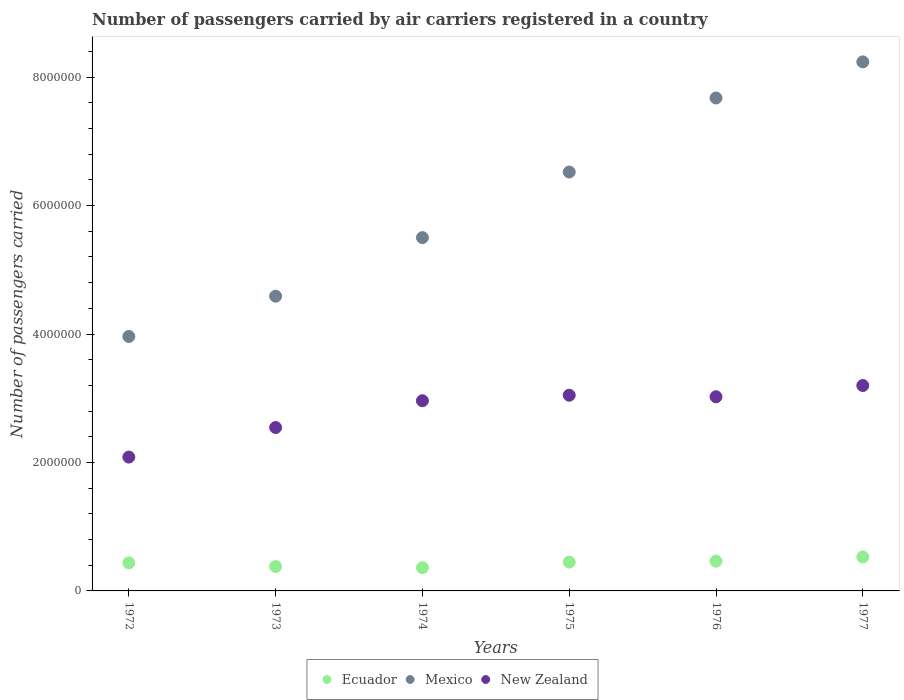How many different coloured dotlines are there?
Your response must be concise. 3. What is the number of passengers carried by air carriers in Ecuador in 1972?
Provide a short and direct response. 4.38e+05. Across all years, what is the maximum number of passengers carried by air carriers in Mexico?
Keep it short and to the point. 8.24e+06. Across all years, what is the minimum number of passengers carried by air carriers in Mexico?
Give a very brief answer. 3.96e+06. In which year was the number of passengers carried by air carriers in New Zealand maximum?
Offer a terse response. 1977. In which year was the number of passengers carried by air carriers in Ecuador minimum?
Offer a terse response. 1974. What is the total number of passengers carried by air carriers in Ecuador in the graph?
Your answer should be very brief. 2.62e+06. What is the difference between the number of passengers carried by air carriers in Ecuador in 1974 and that in 1975?
Provide a succinct answer. -8.59e+04. What is the difference between the number of passengers carried by air carriers in New Zealand in 1973 and the number of passengers carried by air carriers in Mexico in 1974?
Provide a short and direct response. -2.96e+06. What is the average number of passengers carried by air carriers in Ecuador per year?
Give a very brief answer. 4.37e+05. In the year 1974, what is the difference between the number of passengers carried by air carriers in Mexico and number of passengers carried by air carriers in Ecuador?
Ensure brevity in your answer.  5.14e+06. In how many years, is the number of passengers carried by air carriers in New Zealand greater than 6800000?
Your answer should be compact. 0. What is the ratio of the number of passengers carried by air carriers in Mexico in 1972 to that in 1973?
Give a very brief answer. 0.86. Is the difference between the number of passengers carried by air carriers in Mexico in 1972 and 1977 greater than the difference between the number of passengers carried by air carriers in Ecuador in 1972 and 1977?
Your answer should be very brief. No. What is the difference between the highest and the second highest number of passengers carried by air carriers in Mexico?
Your answer should be compact. 5.62e+05. What is the difference between the highest and the lowest number of passengers carried by air carriers in Ecuador?
Make the answer very short. 1.66e+05. In how many years, is the number of passengers carried by air carriers in New Zealand greater than the average number of passengers carried by air carriers in New Zealand taken over all years?
Offer a very short reply. 4. How many years are there in the graph?
Provide a short and direct response. 6. Does the graph contain any zero values?
Provide a succinct answer. No. Does the graph contain grids?
Your answer should be compact. No. Where does the legend appear in the graph?
Make the answer very short. Bottom center. What is the title of the graph?
Provide a short and direct response. Number of passengers carried by air carriers registered in a country. Does "Mauritius" appear as one of the legend labels in the graph?
Provide a short and direct response. No. What is the label or title of the X-axis?
Make the answer very short. Years. What is the label or title of the Y-axis?
Keep it short and to the point. Number of passengers carried. What is the Number of passengers carried in Ecuador in 1972?
Offer a terse response. 4.38e+05. What is the Number of passengers carried of Mexico in 1972?
Provide a short and direct response. 3.96e+06. What is the Number of passengers carried of New Zealand in 1972?
Offer a very short reply. 2.08e+06. What is the Number of passengers carried in Ecuador in 1973?
Provide a succinct answer. 3.80e+05. What is the Number of passengers carried in Mexico in 1973?
Your answer should be very brief. 4.59e+06. What is the Number of passengers carried in New Zealand in 1973?
Make the answer very short. 2.54e+06. What is the Number of passengers carried of Ecuador in 1974?
Offer a very short reply. 3.62e+05. What is the Number of passengers carried in Mexico in 1974?
Offer a very short reply. 5.50e+06. What is the Number of passengers carried in New Zealand in 1974?
Offer a terse response. 2.96e+06. What is the Number of passengers carried in Ecuador in 1975?
Give a very brief answer. 4.48e+05. What is the Number of passengers carried of Mexico in 1975?
Offer a very short reply. 6.52e+06. What is the Number of passengers carried of New Zealand in 1975?
Your answer should be very brief. 3.05e+06. What is the Number of passengers carried of Ecuador in 1976?
Ensure brevity in your answer.  4.63e+05. What is the Number of passengers carried of Mexico in 1976?
Your answer should be compact. 7.68e+06. What is the Number of passengers carried of New Zealand in 1976?
Offer a very short reply. 3.02e+06. What is the Number of passengers carried of Ecuador in 1977?
Your answer should be very brief. 5.29e+05. What is the Number of passengers carried of Mexico in 1977?
Ensure brevity in your answer.  8.24e+06. What is the Number of passengers carried of New Zealand in 1977?
Your response must be concise. 3.20e+06. Across all years, what is the maximum Number of passengers carried in Ecuador?
Your response must be concise. 5.29e+05. Across all years, what is the maximum Number of passengers carried in Mexico?
Your response must be concise. 8.24e+06. Across all years, what is the maximum Number of passengers carried in New Zealand?
Keep it short and to the point. 3.20e+06. Across all years, what is the minimum Number of passengers carried of Ecuador?
Your response must be concise. 3.62e+05. Across all years, what is the minimum Number of passengers carried of Mexico?
Your response must be concise. 3.96e+06. Across all years, what is the minimum Number of passengers carried in New Zealand?
Offer a very short reply. 2.08e+06. What is the total Number of passengers carried in Ecuador in the graph?
Offer a very short reply. 2.62e+06. What is the total Number of passengers carried in Mexico in the graph?
Keep it short and to the point. 3.65e+07. What is the total Number of passengers carried of New Zealand in the graph?
Make the answer very short. 1.69e+07. What is the difference between the Number of passengers carried of Ecuador in 1972 and that in 1973?
Your response must be concise. 5.76e+04. What is the difference between the Number of passengers carried in Mexico in 1972 and that in 1973?
Your response must be concise. -6.28e+05. What is the difference between the Number of passengers carried of New Zealand in 1972 and that in 1973?
Give a very brief answer. -4.60e+05. What is the difference between the Number of passengers carried in Ecuador in 1972 and that in 1974?
Provide a short and direct response. 7.56e+04. What is the difference between the Number of passengers carried of Mexico in 1972 and that in 1974?
Your answer should be very brief. -1.54e+06. What is the difference between the Number of passengers carried in New Zealand in 1972 and that in 1974?
Offer a very short reply. -8.77e+05. What is the difference between the Number of passengers carried in Ecuador in 1972 and that in 1975?
Provide a short and direct response. -1.03e+04. What is the difference between the Number of passengers carried in Mexico in 1972 and that in 1975?
Give a very brief answer. -2.56e+06. What is the difference between the Number of passengers carried of New Zealand in 1972 and that in 1975?
Keep it short and to the point. -9.63e+05. What is the difference between the Number of passengers carried of Ecuador in 1972 and that in 1976?
Provide a succinct answer. -2.55e+04. What is the difference between the Number of passengers carried in Mexico in 1972 and that in 1976?
Provide a short and direct response. -3.71e+06. What is the difference between the Number of passengers carried in New Zealand in 1972 and that in 1976?
Make the answer very short. -9.39e+05. What is the difference between the Number of passengers carried in Ecuador in 1972 and that in 1977?
Your answer should be very brief. -9.08e+04. What is the difference between the Number of passengers carried in Mexico in 1972 and that in 1977?
Keep it short and to the point. -4.28e+06. What is the difference between the Number of passengers carried of New Zealand in 1972 and that in 1977?
Provide a short and direct response. -1.11e+06. What is the difference between the Number of passengers carried of Ecuador in 1973 and that in 1974?
Offer a terse response. 1.80e+04. What is the difference between the Number of passengers carried in Mexico in 1973 and that in 1974?
Keep it short and to the point. -9.12e+05. What is the difference between the Number of passengers carried of New Zealand in 1973 and that in 1974?
Provide a short and direct response. -4.17e+05. What is the difference between the Number of passengers carried of Ecuador in 1973 and that in 1975?
Offer a terse response. -6.79e+04. What is the difference between the Number of passengers carried of Mexico in 1973 and that in 1975?
Your response must be concise. -1.93e+06. What is the difference between the Number of passengers carried in New Zealand in 1973 and that in 1975?
Ensure brevity in your answer.  -5.03e+05. What is the difference between the Number of passengers carried of Ecuador in 1973 and that in 1976?
Keep it short and to the point. -8.31e+04. What is the difference between the Number of passengers carried of Mexico in 1973 and that in 1976?
Your answer should be very brief. -3.09e+06. What is the difference between the Number of passengers carried of New Zealand in 1973 and that in 1976?
Give a very brief answer. -4.79e+05. What is the difference between the Number of passengers carried of Ecuador in 1973 and that in 1977?
Make the answer very short. -1.48e+05. What is the difference between the Number of passengers carried in Mexico in 1973 and that in 1977?
Offer a terse response. -3.65e+06. What is the difference between the Number of passengers carried in New Zealand in 1973 and that in 1977?
Your response must be concise. -6.54e+05. What is the difference between the Number of passengers carried of Ecuador in 1974 and that in 1975?
Make the answer very short. -8.59e+04. What is the difference between the Number of passengers carried in Mexico in 1974 and that in 1975?
Offer a very short reply. -1.02e+06. What is the difference between the Number of passengers carried of New Zealand in 1974 and that in 1975?
Ensure brevity in your answer.  -8.61e+04. What is the difference between the Number of passengers carried of Ecuador in 1974 and that in 1976?
Keep it short and to the point. -1.01e+05. What is the difference between the Number of passengers carried in Mexico in 1974 and that in 1976?
Give a very brief answer. -2.17e+06. What is the difference between the Number of passengers carried of New Zealand in 1974 and that in 1976?
Make the answer very short. -6.19e+04. What is the difference between the Number of passengers carried in Ecuador in 1974 and that in 1977?
Ensure brevity in your answer.  -1.66e+05. What is the difference between the Number of passengers carried of Mexico in 1974 and that in 1977?
Ensure brevity in your answer.  -2.74e+06. What is the difference between the Number of passengers carried in New Zealand in 1974 and that in 1977?
Provide a short and direct response. -2.37e+05. What is the difference between the Number of passengers carried of Ecuador in 1975 and that in 1976?
Offer a very short reply. -1.52e+04. What is the difference between the Number of passengers carried of Mexico in 1975 and that in 1976?
Offer a terse response. -1.15e+06. What is the difference between the Number of passengers carried of New Zealand in 1975 and that in 1976?
Your answer should be very brief. 2.42e+04. What is the difference between the Number of passengers carried of Ecuador in 1975 and that in 1977?
Keep it short and to the point. -8.05e+04. What is the difference between the Number of passengers carried in Mexico in 1975 and that in 1977?
Make the answer very short. -1.72e+06. What is the difference between the Number of passengers carried of New Zealand in 1975 and that in 1977?
Your answer should be very brief. -1.51e+05. What is the difference between the Number of passengers carried of Ecuador in 1976 and that in 1977?
Provide a succinct answer. -6.53e+04. What is the difference between the Number of passengers carried of Mexico in 1976 and that in 1977?
Keep it short and to the point. -5.62e+05. What is the difference between the Number of passengers carried in New Zealand in 1976 and that in 1977?
Give a very brief answer. -1.75e+05. What is the difference between the Number of passengers carried of Ecuador in 1972 and the Number of passengers carried of Mexico in 1973?
Make the answer very short. -4.15e+06. What is the difference between the Number of passengers carried of Ecuador in 1972 and the Number of passengers carried of New Zealand in 1973?
Your answer should be compact. -2.11e+06. What is the difference between the Number of passengers carried in Mexico in 1972 and the Number of passengers carried in New Zealand in 1973?
Ensure brevity in your answer.  1.42e+06. What is the difference between the Number of passengers carried in Ecuador in 1972 and the Number of passengers carried in Mexico in 1974?
Provide a short and direct response. -5.06e+06. What is the difference between the Number of passengers carried of Ecuador in 1972 and the Number of passengers carried of New Zealand in 1974?
Make the answer very short. -2.52e+06. What is the difference between the Number of passengers carried of Mexico in 1972 and the Number of passengers carried of New Zealand in 1974?
Offer a very short reply. 1.00e+06. What is the difference between the Number of passengers carried of Ecuador in 1972 and the Number of passengers carried of Mexico in 1975?
Your response must be concise. -6.09e+06. What is the difference between the Number of passengers carried of Ecuador in 1972 and the Number of passengers carried of New Zealand in 1975?
Your answer should be very brief. -2.61e+06. What is the difference between the Number of passengers carried in Mexico in 1972 and the Number of passengers carried in New Zealand in 1975?
Ensure brevity in your answer.  9.15e+05. What is the difference between the Number of passengers carried in Ecuador in 1972 and the Number of passengers carried in Mexico in 1976?
Keep it short and to the point. -7.24e+06. What is the difference between the Number of passengers carried of Ecuador in 1972 and the Number of passengers carried of New Zealand in 1976?
Provide a succinct answer. -2.59e+06. What is the difference between the Number of passengers carried in Mexico in 1972 and the Number of passengers carried in New Zealand in 1976?
Offer a very short reply. 9.39e+05. What is the difference between the Number of passengers carried of Ecuador in 1972 and the Number of passengers carried of Mexico in 1977?
Ensure brevity in your answer.  -7.80e+06. What is the difference between the Number of passengers carried in Ecuador in 1972 and the Number of passengers carried in New Zealand in 1977?
Ensure brevity in your answer.  -2.76e+06. What is the difference between the Number of passengers carried of Mexico in 1972 and the Number of passengers carried of New Zealand in 1977?
Ensure brevity in your answer.  7.64e+05. What is the difference between the Number of passengers carried of Ecuador in 1973 and the Number of passengers carried of Mexico in 1974?
Your answer should be compact. -5.12e+06. What is the difference between the Number of passengers carried of Ecuador in 1973 and the Number of passengers carried of New Zealand in 1974?
Ensure brevity in your answer.  -2.58e+06. What is the difference between the Number of passengers carried in Mexico in 1973 and the Number of passengers carried in New Zealand in 1974?
Your answer should be very brief. 1.63e+06. What is the difference between the Number of passengers carried in Ecuador in 1973 and the Number of passengers carried in Mexico in 1975?
Offer a very short reply. -6.14e+06. What is the difference between the Number of passengers carried in Ecuador in 1973 and the Number of passengers carried in New Zealand in 1975?
Ensure brevity in your answer.  -2.67e+06. What is the difference between the Number of passengers carried in Mexico in 1973 and the Number of passengers carried in New Zealand in 1975?
Your answer should be very brief. 1.54e+06. What is the difference between the Number of passengers carried of Ecuador in 1973 and the Number of passengers carried of Mexico in 1976?
Offer a very short reply. -7.30e+06. What is the difference between the Number of passengers carried in Ecuador in 1973 and the Number of passengers carried in New Zealand in 1976?
Offer a terse response. -2.64e+06. What is the difference between the Number of passengers carried of Mexico in 1973 and the Number of passengers carried of New Zealand in 1976?
Ensure brevity in your answer.  1.57e+06. What is the difference between the Number of passengers carried of Ecuador in 1973 and the Number of passengers carried of Mexico in 1977?
Offer a very short reply. -7.86e+06. What is the difference between the Number of passengers carried in Ecuador in 1973 and the Number of passengers carried in New Zealand in 1977?
Offer a terse response. -2.82e+06. What is the difference between the Number of passengers carried in Mexico in 1973 and the Number of passengers carried in New Zealand in 1977?
Your answer should be compact. 1.39e+06. What is the difference between the Number of passengers carried of Ecuador in 1974 and the Number of passengers carried of Mexico in 1975?
Make the answer very short. -6.16e+06. What is the difference between the Number of passengers carried of Ecuador in 1974 and the Number of passengers carried of New Zealand in 1975?
Give a very brief answer. -2.69e+06. What is the difference between the Number of passengers carried of Mexico in 1974 and the Number of passengers carried of New Zealand in 1975?
Provide a short and direct response. 2.45e+06. What is the difference between the Number of passengers carried in Ecuador in 1974 and the Number of passengers carried in Mexico in 1976?
Offer a very short reply. -7.31e+06. What is the difference between the Number of passengers carried in Ecuador in 1974 and the Number of passengers carried in New Zealand in 1976?
Offer a very short reply. -2.66e+06. What is the difference between the Number of passengers carried in Mexico in 1974 and the Number of passengers carried in New Zealand in 1976?
Keep it short and to the point. 2.48e+06. What is the difference between the Number of passengers carried of Ecuador in 1974 and the Number of passengers carried of Mexico in 1977?
Keep it short and to the point. -7.88e+06. What is the difference between the Number of passengers carried in Ecuador in 1974 and the Number of passengers carried in New Zealand in 1977?
Offer a very short reply. -2.84e+06. What is the difference between the Number of passengers carried in Mexico in 1974 and the Number of passengers carried in New Zealand in 1977?
Keep it short and to the point. 2.30e+06. What is the difference between the Number of passengers carried in Ecuador in 1975 and the Number of passengers carried in Mexico in 1976?
Offer a terse response. -7.23e+06. What is the difference between the Number of passengers carried in Ecuador in 1975 and the Number of passengers carried in New Zealand in 1976?
Provide a succinct answer. -2.58e+06. What is the difference between the Number of passengers carried in Mexico in 1975 and the Number of passengers carried in New Zealand in 1976?
Your answer should be compact. 3.50e+06. What is the difference between the Number of passengers carried of Ecuador in 1975 and the Number of passengers carried of Mexico in 1977?
Give a very brief answer. -7.79e+06. What is the difference between the Number of passengers carried of Ecuador in 1975 and the Number of passengers carried of New Zealand in 1977?
Your answer should be compact. -2.75e+06. What is the difference between the Number of passengers carried in Mexico in 1975 and the Number of passengers carried in New Zealand in 1977?
Your response must be concise. 3.32e+06. What is the difference between the Number of passengers carried of Ecuador in 1976 and the Number of passengers carried of Mexico in 1977?
Provide a succinct answer. -7.77e+06. What is the difference between the Number of passengers carried in Ecuador in 1976 and the Number of passengers carried in New Zealand in 1977?
Your answer should be compact. -2.74e+06. What is the difference between the Number of passengers carried in Mexico in 1976 and the Number of passengers carried in New Zealand in 1977?
Ensure brevity in your answer.  4.48e+06. What is the average Number of passengers carried of Ecuador per year?
Ensure brevity in your answer.  4.37e+05. What is the average Number of passengers carried of Mexico per year?
Offer a very short reply. 6.08e+06. What is the average Number of passengers carried of New Zealand per year?
Your response must be concise. 2.81e+06. In the year 1972, what is the difference between the Number of passengers carried of Ecuador and Number of passengers carried of Mexico?
Make the answer very short. -3.52e+06. In the year 1972, what is the difference between the Number of passengers carried of Ecuador and Number of passengers carried of New Zealand?
Your response must be concise. -1.65e+06. In the year 1972, what is the difference between the Number of passengers carried in Mexico and Number of passengers carried in New Zealand?
Offer a terse response. 1.88e+06. In the year 1973, what is the difference between the Number of passengers carried in Ecuador and Number of passengers carried in Mexico?
Offer a terse response. -4.21e+06. In the year 1973, what is the difference between the Number of passengers carried in Ecuador and Number of passengers carried in New Zealand?
Provide a succinct answer. -2.16e+06. In the year 1973, what is the difference between the Number of passengers carried of Mexico and Number of passengers carried of New Zealand?
Make the answer very short. 2.05e+06. In the year 1974, what is the difference between the Number of passengers carried in Ecuador and Number of passengers carried in Mexico?
Keep it short and to the point. -5.14e+06. In the year 1974, what is the difference between the Number of passengers carried of Ecuador and Number of passengers carried of New Zealand?
Give a very brief answer. -2.60e+06. In the year 1974, what is the difference between the Number of passengers carried of Mexico and Number of passengers carried of New Zealand?
Your answer should be very brief. 2.54e+06. In the year 1975, what is the difference between the Number of passengers carried of Ecuador and Number of passengers carried of Mexico?
Make the answer very short. -6.07e+06. In the year 1975, what is the difference between the Number of passengers carried of Ecuador and Number of passengers carried of New Zealand?
Your answer should be very brief. -2.60e+06. In the year 1975, what is the difference between the Number of passengers carried of Mexico and Number of passengers carried of New Zealand?
Provide a succinct answer. 3.48e+06. In the year 1976, what is the difference between the Number of passengers carried in Ecuador and Number of passengers carried in Mexico?
Keep it short and to the point. -7.21e+06. In the year 1976, what is the difference between the Number of passengers carried of Ecuador and Number of passengers carried of New Zealand?
Offer a very short reply. -2.56e+06. In the year 1976, what is the difference between the Number of passengers carried of Mexico and Number of passengers carried of New Zealand?
Provide a succinct answer. 4.65e+06. In the year 1977, what is the difference between the Number of passengers carried of Ecuador and Number of passengers carried of Mexico?
Your answer should be very brief. -7.71e+06. In the year 1977, what is the difference between the Number of passengers carried in Ecuador and Number of passengers carried in New Zealand?
Your response must be concise. -2.67e+06. In the year 1977, what is the difference between the Number of passengers carried of Mexico and Number of passengers carried of New Zealand?
Provide a succinct answer. 5.04e+06. What is the ratio of the Number of passengers carried in Ecuador in 1972 to that in 1973?
Provide a succinct answer. 1.15. What is the ratio of the Number of passengers carried of Mexico in 1972 to that in 1973?
Offer a terse response. 0.86. What is the ratio of the Number of passengers carried of New Zealand in 1972 to that in 1973?
Your response must be concise. 0.82. What is the ratio of the Number of passengers carried in Ecuador in 1972 to that in 1974?
Keep it short and to the point. 1.21. What is the ratio of the Number of passengers carried of Mexico in 1972 to that in 1974?
Ensure brevity in your answer.  0.72. What is the ratio of the Number of passengers carried of New Zealand in 1972 to that in 1974?
Provide a succinct answer. 0.7. What is the ratio of the Number of passengers carried in Mexico in 1972 to that in 1975?
Keep it short and to the point. 0.61. What is the ratio of the Number of passengers carried in New Zealand in 1972 to that in 1975?
Ensure brevity in your answer.  0.68. What is the ratio of the Number of passengers carried in Ecuador in 1972 to that in 1976?
Give a very brief answer. 0.94. What is the ratio of the Number of passengers carried of Mexico in 1972 to that in 1976?
Ensure brevity in your answer.  0.52. What is the ratio of the Number of passengers carried of New Zealand in 1972 to that in 1976?
Your answer should be compact. 0.69. What is the ratio of the Number of passengers carried in Ecuador in 1972 to that in 1977?
Provide a short and direct response. 0.83. What is the ratio of the Number of passengers carried of Mexico in 1972 to that in 1977?
Provide a short and direct response. 0.48. What is the ratio of the Number of passengers carried in New Zealand in 1972 to that in 1977?
Your answer should be compact. 0.65. What is the ratio of the Number of passengers carried in Ecuador in 1973 to that in 1974?
Give a very brief answer. 1.05. What is the ratio of the Number of passengers carried in Mexico in 1973 to that in 1974?
Your answer should be compact. 0.83. What is the ratio of the Number of passengers carried in New Zealand in 1973 to that in 1974?
Provide a short and direct response. 0.86. What is the ratio of the Number of passengers carried in Ecuador in 1973 to that in 1975?
Offer a terse response. 0.85. What is the ratio of the Number of passengers carried in Mexico in 1973 to that in 1975?
Offer a very short reply. 0.7. What is the ratio of the Number of passengers carried of New Zealand in 1973 to that in 1975?
Ensure brevity in your answer.  0.83. What is the ratio of the Number of passengers carried of Ecuador in 1973 to that in 1976?
Provide a succinct answer. 0.82. What is the ratio of the Number of passengers carried of Mexico in 1973 to that in 1976?
Your answer should be compact. 0.6. What is the ratio of the Number of passengers carried in New Zealand in 1973 to that in 1976?
Ensure brevity in your answer.  0.84. What is the ratio of the Number of passengers carried in Ecuador in 1973 to that in 1977?
Offer a terse response. 0.72. What is the ratio of the Number of passengers carried of Mexico in 1973 to that in 1977?
Provide a short and direct response. 0.56. What is the ratio of the Number of passengers carried in New Zealand in 1973 to that in 1977?
Give a very brief answer. 0.8. What is the ratio of the Number of passengers carried in Ecuador in 1974 to that in 1975?
Your answer should be very brief. 0.81. What is the ratio of the Number of passengers carried of Mexico in 1974 to that in 1975?
Give a very brief answer. 0.84. What is the ratio of the Number of passengers carried of New Zealand in 1974 to that in 1975?
Provide a short and direct response. 0.97. What is the ratio of the Number of passengers carried of Ecuador in 1974 to that in 1976?
Give a very brief answer. 0.78. What is the ratio of the Number of passengers carried of Mexico in 1974 to that in 1976?
Offer a very short reply. 0.72. What is the ratio of the Number of passengers carried in New Zealand in 1974 to that in 1976?
Provide a short and direct response. 0.98. What is the ratio of the Number of passengers carried of Ecuador in 1974 to that in 1977?
Your answer should be compact. 0.69. What is the ratio of the Number of passengers carried of Mexico in 1974 to that in 1977?
Ensure brevity in your answer.  0.67. What is the ratio of the Number of passengers carried of New Zealand in 1974 to that in 1977?
Your answer should be compact. 0.93. What is the ratio of the Number of passengers carried in Ecuador in 1975 to that in 1976?
Provide a short and direct response. 0.97. What is the ratio of the Number of passengers carried of Mexico in 1975 to that in 1976?
Keep it short and to the point. 0.85. What is the ratio of the Number of passengers carried of New Zealand in 1975 to that in 1976?
Provide a short and direct response. 1.01. What is the ratio of the Number of passengers carried in Ecuador in 1975 to that in 1977?
Your answer should be very brief. 0.85. What is the ratio of the Number of passengers carried of Mexico in 1975 to that in 1977?
Provide a short and direct response. 0.79. What is the ratio of the Number of passengers carried of New Zealand in 1975 to that in 1977?
Make the answer very short. 0.95. What is the ratio of the Number of passengers carried in Ecuador in 1976 to that in 1977?
Provide a short and direct response. 0.88. What is the ratio of the Number of passengers carried of Mexico in 1976 to that in 1977?
Your answer should be very brief. 0.93. What is the ratio of the Number of passengers carried of New Zealand in 1976 to that in 1977?
Offer a terse response. 0.95. What is the difference between the highest and the second highest Number of passengers carried in Ecuador?
Offer a terse response. 6.53e+04. What is the difference between the highest and the second highest Number of passengers carried of Mexico?
Your answer should be compact. 5.62e+05. What is the difference between the highest and the second highest Number of passengers carried in New Zealand?
Your answer should be compact. 1.51e+05. What is the difference between the highest and the lowest Number of passengers carried of Ecuador?
Provide a short and direct response. 1.66e+05. What is the difference between the highest and the lowest Number of passengers carried of Mexico?
Provide a succinct answer. 4.28e+06. What is the difference between the highest and the lowest Number of passengers carried of New Zealand?
Your answer should be compact. 1.11e+06. 